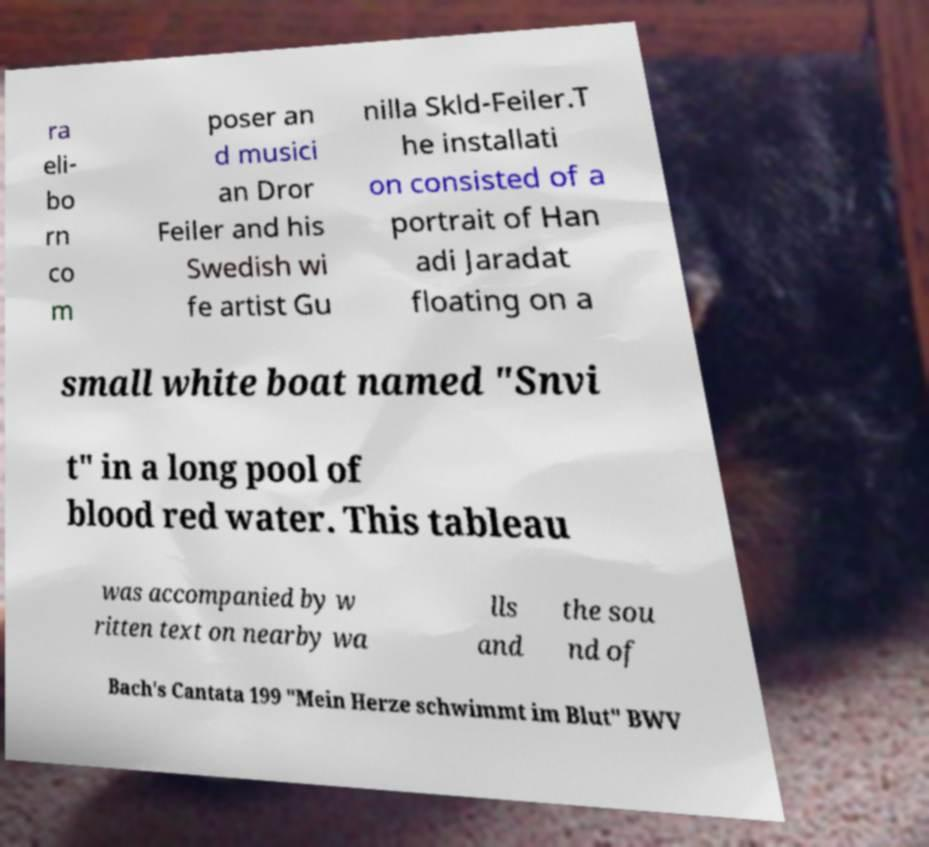Could you extract and type out the text from this image? ra eli- bo rn co m poser an d musici an Dror Feiler and his Swedish wi fe artist Gu nilla Skld-Feiler.T he installati on consisted of a portrait of Han adi Jaradat floating on a small white boat named "Snvi t" in a long pool of blood red water. This tableau was accompanied by w ritten text on nearby wa lls and the sou nd of Bach's Cantata 199 "Mein Herze schwimmt im Blut" BWV 